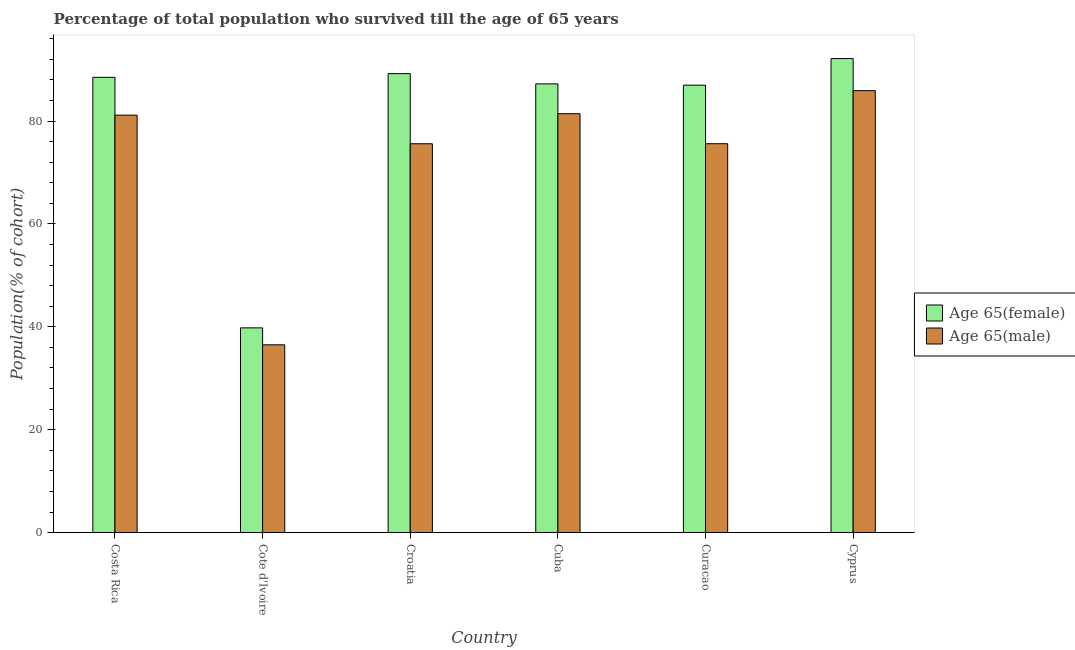How many different coloured bars are there?
Your answer should be compact. 2. How many groups of bars are there?
Provide a succinct answer. 6. How many bars are there on the 5th tick from the right?
Ensure brevity in your answer.  2. What is the label of the 2nd group of bars from the left?
Offer a terse response. Cote d'Ivoire. What is the percentage of male population who survived till age of 65 in Curacao?
Your answer should be compact. 75.59. Across all countries, what is the maximum percentage of male population who survived till age of 65?
Provide a succinct answer. 85.9. Across all countries, what is the minimum percentage of male population who survived till age of 65?
Your response must be concise. 36.5. In which country was the percentage of female population who survived till age of 65 maximum?
Offer a very short reply. Cyprus. In which country was the percentage of female population who survived till age of 65 minimum?
Ensure brevity in your answer.  Cote d'Ivoire. What is the total percentage of female population who survived till age of 65 in the graph?
Offer a terse response. 483.83. What is the difference between the percentage of male population who survived till age of 65 in Cote d'Ivoire and that in Cuba?
Provide a short and direct response. -44.92. What is the difference between the percentage of male population who survived till age of 65 in Croatia and the percentage of female population who survived till age of 65 in Curacao?
Provide a succinct answer. -11.39. What is the average percentage of male population who survived till age of 65 per country?
Your answer should be compact. 72.69. What is the difference between the percentage of male population who survived till age of 65 and percentage of female population who survived till age of 65 in Cote d'Ivoire?
Make the answer very short. -3.29. In how many countries, is the percentage of male population who survived till age of 65 greater than 68 %?
Your response must be concise. 5. What is the ratio of the percentage of male population who survived till age of 65 in Costa Rica to that in Croatia?
Ensure brevity in your answer.  1.07. What is the difference between the highest and the second highest percentage of male population who survived till age of 65?
Your answer should be very brief. 4.48. What is the difference between the highest and the lowest percentage of female population who survived till age of 65?
Your answer should be very brief. 52.35. Is the sum of the percentage of female population who survived till age of 65 in Costa Rica and Cyprus greater than the maximum percentage of male population who survived till age of 65 across all countries?
Your response must be concise. Yes. What does the 2nd bar from the left in Croatia represents?
Your response must be concise. Age 65(male). What does the 2nd bar from the right in Cyprus represents?
Keep it short and to the point. Age 65(female). How many bars are there?
Ensure brevity in your answer.  12. How many countries are there in the graph?
Provide a succinct answer. 6. Does the graph contain any zero values?
Offer a terse response. No. Does the graph contain grids?
Offer a very short reply. No. What is the title of the graph?
Keep it short and to the point. Percentage of total population who survived till the age of 65 years. What is the label or title of the Y-axis?
Provide a succinct answer. Population(% of cohort). What is the Population(% of cohort) in Age 65(female) in Costa Rica?
Your response must be concise. 88.49. What is the Population(% of cohort) in Age 65(male) in Costa Rica?
Provide a succinct answer. 81.14. What is the Population(% of cohort) of Age 65(female) in Cote d'Ivoire?
Your answer should be compact. 39.79. What is the Population(% of cohort) of Age 65(male) in Cote d'Ivoire?
Keep it short and to the point. 36.5. What is the Population(% of cohort) in Age 65(female) in Croatia?
Provide a succinct answer. 89.21. What is the Population(% of cohort) of Age 65(male) in Croatia?
Give a very brief answer. 75.58. What is the Population(% of cohort) in Age 65(female) in Cuba?
Give a very brief answer. 87.22. What is the Population(% of cohort) in Age 65(male) in Cuba?
Keep it short and to the point. 81.42. What is the Population(% of cohort) in Age 65(female) in Curacao?
Ensure brevity in your answer.  86.97. What is the Population(% of cohort) of Age 65(male) in Curacao?
Your answer should be compact. 75.59. What is the Population(% of cohort) in Age 65(female) in Cyprus?
Make the answer very short. 92.14. What is the Population(% of cohort) of Age 65(male) in Cyprus?
Provide a short and direct response. 85.9. Across all countries, what is the maximum Population(% of cohort) of Age 65(female)?
Give a very brief answer. 92.14. Across all countries, what is the maximum Population(% of cohort) in Age 65(male)?
Ensure brevity in your answer.  85.9. Across all countries, what is the minimum Population(% of cohort) in Age 65(female)?
Give a very brief answer. 39.79. Across all countries, what is the minimum Population(% of cohort) in Age 65(male)?
Offer a very short reply. 36.5. What is the total Population(% of cohort) of Age 65(female) in the graph?
Give a very brief answer. 483.83. What is the total Population(% of cohort) of Age 65(male) in the graph?
Offer a very short reply. 436.14. What is the difference between the Population(% of cohort) in Age 65(female) in Costa Rica and that in Cote d'Ivoire?
Your response must be concise. 48.7. What is the difference between the Population(% of cohort) of Age 65(male) in Costa Rica and that in Cote d'Ivoire?
Ensure brevity in your answer.  44.64. What is the difference between the Population(% of cohort) of Age 65(female) in Costa Rica and that in Croatia?
Provide a short and direct response. -0.71. What is the difference between the Population(% of cohort) in Age 65(male) in Costa Rica and that in Croatia?
Give a very brief answer. 5.56. What is the difference between the Population(% of cohort) of Age 65(female) in Costa Rica and that in Cuba?
Your answer should be very brief. 1.27. What is the difference between the Population(% of cohort) of Age 65(male) in Costa Rica and that in Cuba?
Offer a terse response. -0.28. What is the difference between the Population(% of cohort) of Age 65(female) in Costa Rica and that in Curacao?
Keep it short and to the point. 1.52. What is the difference between the Population(% of cohort) of Age 65(male) in Costa Rica and that in Curacao?
Provide a short and direct response. 5.55. What is the difference between the Population(% of cohort) in Age 65(female) in Costa Rica and that in Cyprus?
Make the answer very short. -3.64. What is the difference between the Population(% of cohort) of Age 65(male) in Costa Rica and that in Cyprus?
Your answer should be compact. -4.76. What is the difference between the Population(% of cohort) of Age 65(female) in Cote d'Ivoire and that in Croatia?
Give a very brief answer. -49.42. What is the difference between the Population(% of cohort) of Age 65(male) in Cote d'Ivoire and that in Croatia?
Your answer should be very brief. -39.08. What is the difference between the Population(% of cohort) in Age 65(female) in Cote d'Ivoire and that in Cuba?
Provide a short and direct response. -47.43. What is the difference between the Population(% of cohort) in Age 65(male) in Cote d'Ivoire and that in Cuba?
Provide a short and direct response. -44.92. What is the difference between the Population(% of cohort) of Age 65(female) in Cote d'Ivoire and that in Curacao?
Provide a succinct answer. -47.18. What is the difference between the Population(% of cohort) in Age 65(male) in Cote d'Ivoire and that in Curacao?
Offer a very short reply. -39.09. What is the difference between the Population(% of cohort) of Age 65(female) in Cote d'Ivoire and that in Cyprus?
Provide a succinct answer. -52.35. What is the difference between the Population(% of cohort) of Age 65(male) in Cote d'Ivoire and that in Cyprus?
Your response must be concise. -49.41. What is the difference between the Population(% of cohort) in Age 65(female) in Croatia and that in Cuba?
Keep it short and to the point. 1.99. What is the difference between the Population(% of cohort) of Age 65(male) in Croatia and that in Cuba?
Your answer should be very brief. -5.84. What is the difference between the Population(% of cohort) of Age 65(female) in Croatia and that in Curacao?
Your response must be concise. 2.24. What is the difference between the Population(% of cohort) in Age 65(male) in Croatia and that in Curacao?
Ensure brevity in your answer.  -0.01. What is the difference between the Population(% of cohort) in Age 65(female) in Croatia and that in Cyprus?
Provide a succinct answer. -2.93. What is the difference between the Population(% of cohort) in Age 65(male) in Croatia and that in Cyprus?
Provide a succinct answer. -10.32. What is the difference between the Population(% of cohort) of Age 65(female) in Cuba and that in Curacao?
Make the answer very short. 0.25. What is the difference between the Population(% of cohort) of Age 65(male) in Cuba and that in Curacao?
Your response must be concise. 5.83. What is the difference between the Population(% of cohort) in Age 65(female) in Cuba and that in Cyprus?
Offer a terse response. -4.92. What is the difference between the Population(% of cohort) in Age 65(male) in Cuba and that in Cyprus?
Make the answer very short. -4.48. What is the difference between the Population(% of cohort) in Age 65(female) in Curacao and that in Cyprus?
Your answer should be compact. -5.17. What is the difference between the Population(% of cohort) of Age 65(male) in Curacao and that in Cyprus?
Provide a succinct answer. -10.31. What is the difference between the Population(% of cohort) of Age 65(female) in Costa Rica and the Population(% of cohort) of Age 65(male) in Cote d'Ivoire?
Ensure brevity in your answer.  52. What is the difference between the Population(% of cohort) in Age 65(female) in Costa Rica and the Population(% of cohort) in Age 65(male) in Croatia?
Your answer should be very brief. 12.91. What is the difference between the Population(% of cohort) in Age 65(female) in Costa Rica and the Population(% of cohort) in Age 65(male) in Cuba?
Your response must be concise. 7.07. What is the difference between the Population(% of cohort) in Age 65(female) in Costa Rica and the Population(% of cohort) in Age 65(male) in Curacao?
Your answer should be compact. 12.91. What is the difference between the Population(% of cohort) in Age 65(female) in Costa Rica and the Population(% of cohort) in Age 65(male) in Cyprus?
Provide a short and direct response. 2.59. What is the difference between the Population(% of cohort) of Age 65(female) in Cote d'Ivoire and the Population(% of cohort) of Age 65(male) in Croatia?
Offer a terse response. -35.79. What is the difference between the Population(% of cohort) in Age 65(female) in Cote d'Ivoire and the Population(% of cohort) in Age 65(male) in Cuba?
Make the answer very short. -41.63. What is the difference between the Population(% of cohort) in Age 65(female) in Cote d'Ivoire and the Population(% of cohort) in Age 65(male) in Curacao?
Your answer should be compact. -35.8. What is the difference between the Population(% of cohort) of Age 65(female) in Cote d'Ivoire and the Population(% of cohort) of Age 65(male) in Cyprus?
Your response must be concise. -46.11. What is the difference between the Population(% of cohort) of Age 65(female) in Croatia and the Population(% of cohort) of Age 65(male) in Cuba?
Give a very brief answer. 7.79. What is the difference between the Population(% of cohort) of Age 65(female) in Croatia and the Population(% of cohort) of Age 65(male) in Curacao?
Your answer should be compact. 13.62. What is the difference between the Population(% of cohort) of Age 65(female) in Croatia and the Population(% of cohort) of Age 65(male) in Cyprus?
Offer a very short reply. 3.3. What is the difference between the Population(% of cohort) in Age 65(female) in Cuba and the Population(% of cohort) in Age 65(male) in Curacao?
Your answer should be very brief. 11.63. What is the difference between the Population(% of cohort) in Age 65(female) in Cuba and the Population(% of cohort) in Age 65(male) in Cyprus?
Your answer should be compact. 1.32. What is the difference between the Population(% of cohort) of Age 65(female) in Curacao and the Population(% of cohort) of Age 65(male) in Cyprus?
Your answer should be compact. 1.07. What is the average Population(% of cohort) in Age 65(female) per country?
Give a very brief answer. 80.64. What is the average Population(% of cohort) of Age 65(male) per country?
Provide a succinct answer. 72.69. What is the difference between the Population(% of cohort) of Age 65(female) and Population(% of cohort) of Age 65(male) in Costa Rica?
Offer a terse response. 7.35. What is the difference between the Population(% of cohort) in Age 65(female) and Population(% of cohort) in Age 65(male) in Cote d'Ivoire?
Give a very brief answer. 3.29. What is the difference between the Population(% of cohort) of Age 65(female) and Population(% of cohort) of Age 65(male) in Croatia?
Your answer should be compact. 13.63. What is the difference between the Population(% of cohort) in Age 65(female) and Population(% of cohort) in Age 65(male) in Cuba?
Make the answer very short. 5.8. What is the difference between the Population(% of cohort) in Age 65(female) and Population(% of cohort) in Age 65(male) in Curacao?
Offer a terse response. 11.38. What is the difference between the Population(% of cohort) of Age 65(female) and Population(% of cohort) of Age 65(male) in Cyprus?
Offer a terse response. 6.23. What is the ratio of the Population(% of cohort) of Age 65(female) in Costa Rica to that in Cote d'Ivoire?
Provide a short and direct response. 2.22. What is the ratio of the Population(% of cohort) in Age 65(male) in Costa Rica to that in Cote d'Ivoire?
Keep it short and to the point. 2.22. What is the ratio of the Population(% of cohort) of Age 65(male) in Costa Rica to that in Croatia?
Your answer should be very brief. 1.07. What is the ratio of the Population(% of cohort) of Age 65(female) in Costa Rica to that in Cuba?
Provide a short and direct response. 1.01. What is the ratio of the Population(% of cohort) in Age 65(female) in Costa Rica to that in Curacao?
Provide a short and direct response. 1.02. What is the ratio of the Population(% of cohort) in Age 65(male) in Costa Rica to that in Curacao?
Keep it short and to the point. 1.07. What is the ratio of the Population(% of cohort) in Age 65(female) in Costa Rica to that in Cyprus?
Provide a short and direct response. 0.96. What is the ratio of the Population(% of cohort) in Age 65(male) in Costa Rica to that in Cyprus?
Ensure brevity in your answer.  0.94. What is the ratio of the Population(% of cohort) in Age 65(female) in Cote d'Ivoire to that in Croatia?
Your answer should be very brief. 0.45. What is the ratio of the Population(% of cohort) in Age 65(male) in Cote d'Ivoire to that in Croatia?
Offer a terse response. 0.48. What is the ratio of the Population(% of cohort) of Age 65(female) in Cote d'Ivoire to that in Cuba?
Your response must be concise. 0.46. What is the ratio of the Population(% of cohort) in Age 65(male) in Cote d'Ivoire to that in Cuba?
Your answer should be very brief. 0.45. What is the ratio of the Population(% of cohort) in Age 65(female) in Cote d'Ivoire to that in Curacao?
Provide a short and direct response. 0.46. What is the ratio of the Population(% of cohort) of Age 65(male) in Cote d'Ivoire to that in Curacao?
Make the answer very short. 0.48. What is the ratio of the Population(% of cohort) in Age 65(female) in Cote d'Ivoire to that in Cyprus?
Your answer should be compact. 0.43. What is the ratio of the Population(% of cohort) in Age 65(male) in Cote d'Ivoire to that in Cyprus?
Keep it short and to the point. 0.42. What is the ratio of the Population(% of cohort) in Age 65(female) in Croatia to that in Cuba?
Ensure brevity in your answer.  1.02. What is the ratio of the Population(% of cohort) of Age 65(male) in Croatia to that in Cuba?
Make the answer very short. 0.93. What is the ratio of the Population(% of cohort) of Age 65(female) in Croatia to that in Curacao?
Your answer should be very brief. 1.03. What is the ratio of the Population(% of cohort) of Age 65(female) in Croatia to that in Cyprus?
Your answer should be very brief. 0.97. What is the ratio of the Population(% of cohort) in Age 65(male) in Croatia to that in Cyprus?
Provide a succinct answer. 0.88. What is the ratio of the Population(% of cohort) in Age 65(female) in Cuba to that in Curacao?
Your answer should be very brief. 1. What is the ratio of the Population(% of cohort) in Age 65(male) in Cuba to that in Curacao?
Your response must be concise. 1.08. What is the ratio of the Population(% of cohort) in Age 65(female) in Cuba to that in Cyprus?
Your answer should be compact. 0.95. What is the ratio of the Population(% of cohort) of Age 65(male) in Cuba to that in Cyprus?
Keep it short and to the point. 0.95. What is the ratio of the Population(% of cohort) in Age 65(female) in Curacao to that in Cyprus?
Offer a very short reply. 0.94. What is the ratio of the Population(% of cohort) of Age 65(male) in Curacao to that in Cyprus?
Provide a short and direct response. 0.88. What is the difference between the highest and the second highest Population(% of cohort) of Age 65(female)?
Offer a terse response. 2.93. What is the difference between the highest and the second highest Population(% of cohort) of Age 65(male)?
Give a very brief answer. 4.48. What is the difference between the highest and the lowest Population(% of cohort) in Age 65(female)?
Your response must be concise. 52.35. What is the difference between the highest and the lowest Population(% of cohort) of Age 65(male)?
Your response must be concise. 49.41. 